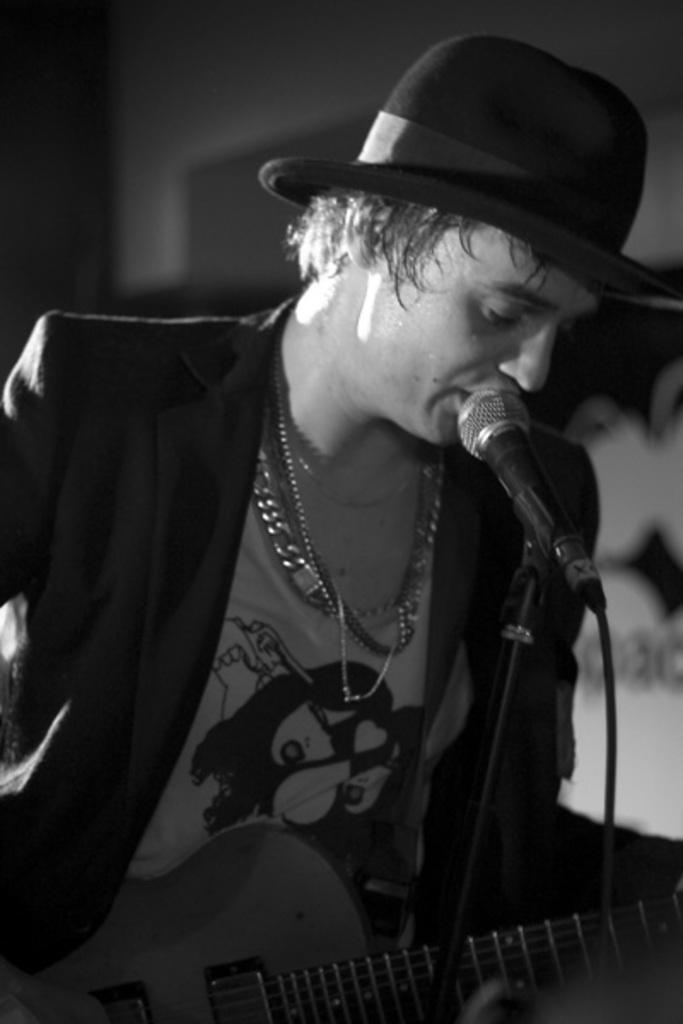Can you describe this image briefly? In this image I see a man who holding the guitar and there is a mic in front of him. 